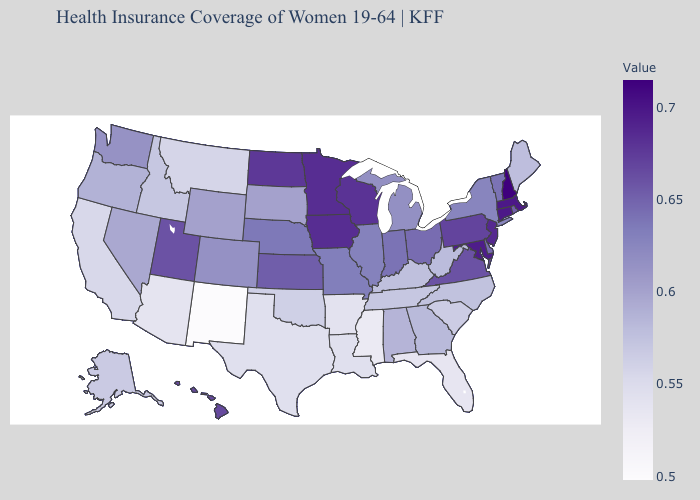Which states hav the highest value in the South?
Answer briefly. Maryland. 